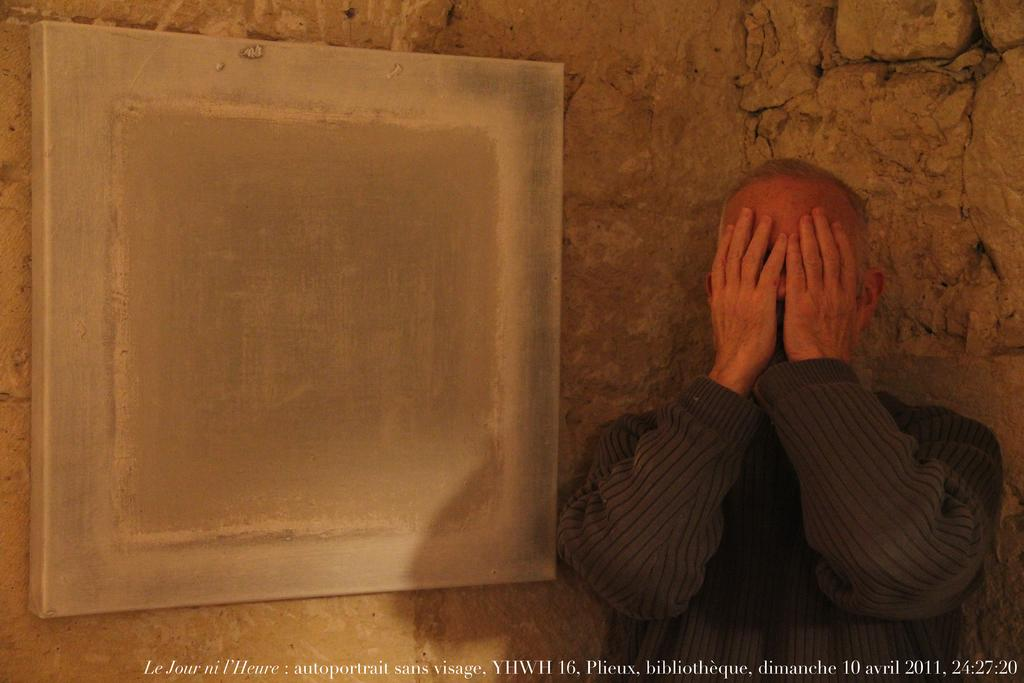Who or what is present in the image? There is a person in the image. What else can be seen in the image besides the person? There is text and a board in the image. What type of background is visible in the image? There is a wall of stones in the image, which may suggest that the image was taken in a building. What type of pie is being served on the wall in the image? There is no pie present in the image; the wall is made of stones. 